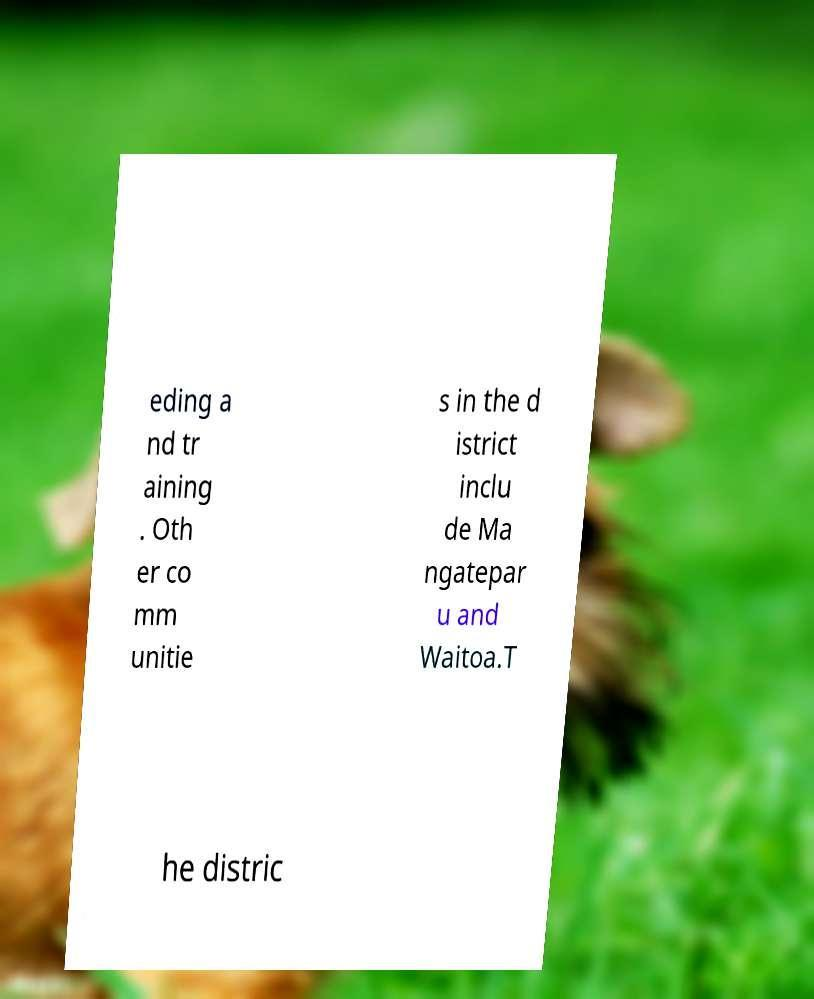What messages or text are displayed in this image? I need them in a readable, typed format. eding a nd tr aining . Oth er co mm unitie s in the d istrict inclu de Ma ngatepar u and Waitoa.T he distric 